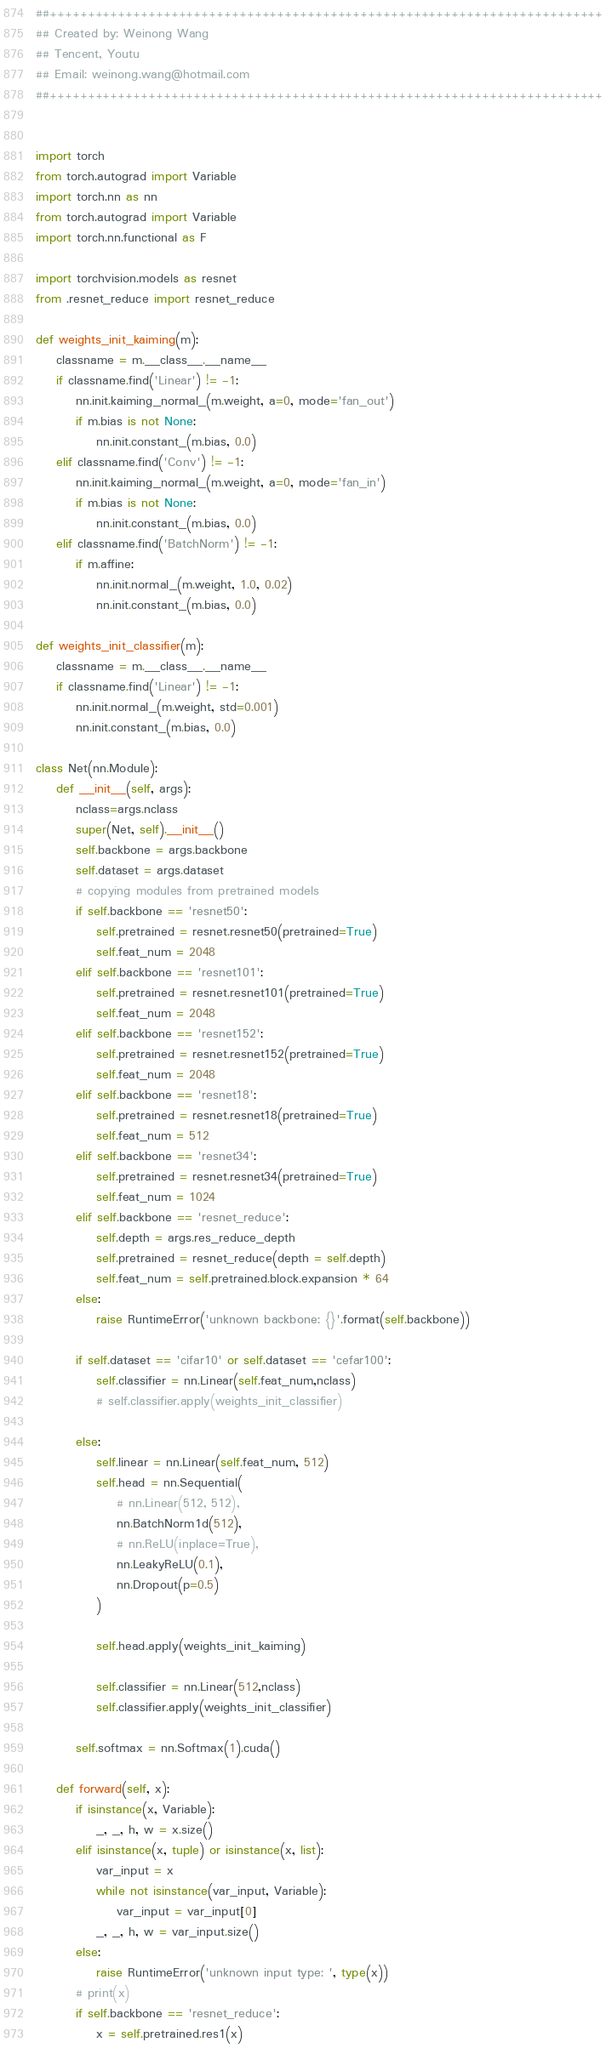Convert code to text. <code><loc_0><loc_0><loc_500><loc_500><_Python_>##+++++++++++++++++++++++++++++++++++++++++++++++++++++++++++++++++++++++++
## Created by: Weinong Wang
## Tencent, Youtu
## Email: weinong.wang@hotmail.com
##+++++++++++++++++++++++++++++++++++++++++++++++++++++++++++++++++++++++++


import torch
from torch.autograd import Variable
import torch.nn as nn
from torch.autograd import Variable
import torch.nn.functional as F

import torchvision.models as resnet
from .resnet_reduce import resnet_reduce

def weights_init_kaiming(m):
    classname = m.__class__.__name__
    if classname.find('Linear') != -1:
        nn.init.kaiming_normal_(m.weight, a=0, mode='fan_out')
        if m.bias is not None:
            nn.init.constant_(m.bias, 0.0)
    elif classname.find('Conv') != -1:
        nn.init.kaiming_normal_(m.weight, a=0, mode='fan_in')
        if m.bias is not None:
            nn.init.constant_(m.bias, 0.0)
    elif classname.find('BatchNorm') != -1:
        if m.affine:
            nn.init.normal_(m.weight, 1.0, 0.02)
            nn.init.constant_(m.bias, 0.0)

def weights_init_classifier(m):
    classname = m.__class__.__name__
    if classname.find('Linear') != -1:
        nn.init.normal_(m.weight, std=0.001)
        nn.init.constant_(m.bias, 0.0)

class Net(nn.Module):
    def __init__(self, args):
        nclass=args.nclass
        super(Net, self).__init__()
        self.backbone = args.backbone
        self.dataset = args.dataset
        # copying modules from pretrained models
        if self.backbone == 'resnet50':
            self.pretrained = resnet.resnet50(pretrained=True)
            self.feat_num = 2048
        elif self.backbone == 'resnet101':
            self.pretrained = resnet.resnet101(pretrained=True)
            self.feat_num = 2048
        elif self.backbone == 'resnet152':
            self.pretrained = resnet.resnet152(pretrained=True)
            self.feat_num = 2048
        elif self.backbone == 'resnet18':
            self.pretrained = resnet.resnet18(pretrained=True)
            self.feat_num = 512
        elif self.backbone == 'resnet34':
            self.pretrained = resnet.resnet34(pretrained=True)
            self.feat_num = 1024
        elif self.backbone == 'resnet_reduce':
            self.depth = args.res_reduce_depth
            self.pretrained = resnet_reduce(depth = self.depth)
            self.feat_num = self.pretrained.block.expansion * 64
        else:
            raise RuntimeError('unknown backbone: {}'.format(self.backbone))

        if self.dataset == 'cifar10' or self.dataset == 'cefar100':
            self.classifier = nn.Linear(self.feat_num,nclass)
            # self.classifier.apply(weights_init_classifier)

        else:
            self.linear = nn.Linear(self.feat_num, 512)
            self.head = nn.Sequential(
                # nn.Linear(512, 512),
                nn.BatchNorm1d(512),
                # nn.ReLU(inplace=True),
                nn.LeakyReLU(0.1),
                nn.Dropout(p=0.5)
            )

            self.head.apply(weights_init_kaiming)

            self.classifier = nn.Linear(512,nclass)
            self.classifier.apply(weights_init_classifier)

        self.softmax = nn.Softmax(1).cuda()

    def forward(self, x):
        if isinstance(x, Variable):
            _, _, h, w = x.size()
        elif isinstance(x, tuple) or isinstance(x, list):
            var_input = x 
            while not isinstance(var_input, Variable):
                var_input = var_input[0]
            _, _, h, w = var_input.size()
        else:
            raise RuntimeError('unknown input type: ', type(x))
        # print(x)
        if self.backbone == 'resnet_reduce':
            x = self.pretrained.res1(x)  </code> 